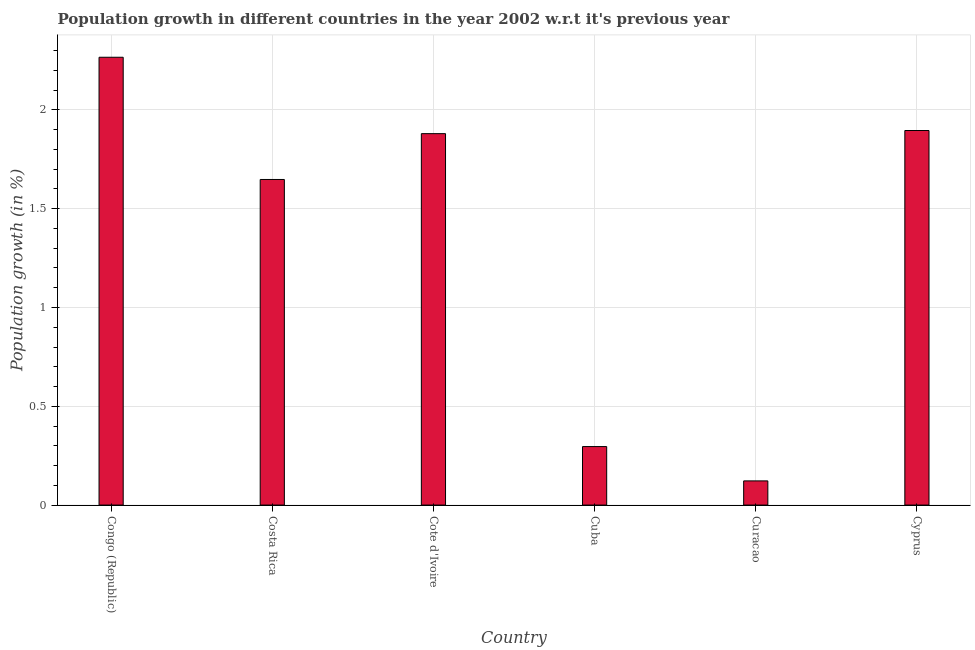What is the title of the graph?
Keep it short and to the point. Population growth in different countries in the year 2002 w.r.t it's previous year. What is the label or title of the X-axis?
Give a very brief answer. Country. What is the label or title of the Y-axis?
Your answer should be very brief. Population growth (in %). What is the population growth in Congo (Republic)?
Offer a terse response. 2.27. Across all countries, what is the maximum population growth?
Ensure brevity in your answer.  2.27. Across all countries, what is the minimum population growth?
Your answer should be very brief. 0.12. In which country was the population growth maximum?
Give a very brief answer. Congo (Republic). In which country was the population growth minimum?
Provide a succinct answer. Curacao. What is the sum of the population growth?
Provide a succinct answer. 8.11. What is the difference between the population growth in Cuba and Curacao?
Your answer should be very brief. 0.17. What is the average population growth per country?
Ensure brevity in your answer.  1.35. What is the median population growth?
Provide a short and direct response. 1.76. What is the ratio of the population growth in Congo (Republic) to that in Cyprus?
Your response must be concise. 1.2. Is the difference between the population growth in Costa Rica and Cyprus greater than the difference between any two countries?
Provide a succinct answer. No. What is the difference between the highest and the second highest population growth?
Keep it short and to the point. 0.37. Is the sum of the population growth in Costa Rica and Cote d'Ivoire greater than the maximum population growth across all countries?
Make the answer very short. Yes. What is the difference between the highest and the lowest population growth?
Offer a terse response. 2.14. In how many countries, is the population growth greater than the average population growth taken over all countries?
Give a very brief answer. 4. How many bars are there?
Your response must be concise. 6. How many countries are there in the graph?
Provide a short and direct response. 6. Are the values on the major ticks of Y-axis written in scientific E-notation?
Give a very brief answer. No. What is the Population growth (in %) in Congo (Republic)?
Your answer should be compact. 2.27. What is the Population growth (in %) of Costa Rica?
Offer a terse response. 1.65. What is the Population growth (in %) of Cote d'Ivoire?
Ensure brevity in your answer.  1.88. What is the Population growth (in %) in Cuba?
Keep it short and to the point. 0.3. What is the Population growth (in %) of Curacao?
Your answer should be very brief. 0.12. What is the Population growth (in %) of Cyprus?
Your response must be concise. 1.9. What is the difference between the Population growth (in %) in Congo (Republic) and Costa Rica?
Give a very brief answer. 0.62. What is the difference between the Population growth (in %) in Congo (Republic) and Cote d'Ivoire?
Provide a short and direct response. 0.39. What is the difference between the Population growth (in %) in Congo (Republic) and Cuba?
Your answer should be very brief. 1.97. What is the difference between the Population growth (in %) in Congo (Republic) and Curacao?
Keep it short and to the point. 2.14. What is the difference between the Population growth (in %) in Congo (Republic) and Cyprus?
Your answer should be compact. 0.37. What is the difference between the Population growth (in %) in Costa Rica and Cote d'Ivoire?
Offer a terse response. -0.23. What is the difference between the Population growth (in %) in Costa Rica and Cuba?
Give a very brief answer. 1.35. What is the difference between the Population growth (in %) in Costa Rica and Curacao?
Your answer should be compact. 1.53. What is the difference between the Population growth (in %) in Costa Rica and Cyprus?
Provide a succinct answer. -0.25. What is the difference between the Population growth (in %) in Cote d'Ivoire and Cuba?
Make the answer very short. 1.58. What is the difference between the Population growth (in %) in Cote d'Ivoire and Curacao?
Give a very brief answer. 1.76. What is the difference between the Population growth (in %) in Cote d'Ivoire and Cyprus?
Make the answer very short. -0.02. What is the difference between the Population growth (in %) in Cuba and Curacao?
Provide a short and direct response. 0.17. What is the difference between the Population growth (in %) in Cuba and Cyprus?
Offer a very short reply. -1.6. What is the difference between the Population growth (in %) in Curacao and Cyprus?
Your answer should be compact. -1.77. What is the ratio of the Population growth (in %) in Congo (Republic) to that in Costa Rica?
Offer a very short reply. 1.38. What is the ratio of the Population growth (in %) in Congo (Republic) to that in Cote d'Ivoire?
Offer a very short reply. 1.21. What is the ratio of the Population growth (in %) in Congo (Republic) to that in Cuba?
Keep it short and to the point. 7.65. What is the ratio of the Population growth (in %) in Congo (Republic) to that in Curacao?
Offer a very short reply. 18.52. What is the ratio of the Population growth (in %) in Congo (Republic) to that in Cyprus?
Give a very brief answer. 1.2. What is the ratio of the Population growth (in %) in Costa Rica to that in Cote d'Ivoire?
Give a very brief answer. 0.88. What is the ratio of the Population growth (in %) in Costa Rica to that in Cuba?
Make the answer very short. 5.57. What is the ratio of the Population growth (in %) in Costa Rica to that in Curacao?
Ensure brevity in your answer.  13.47. What is the ratio of the Population growth (in %) in Costa Rica to that in Cyprus?
Provide a short and direct response. 0.87. What is the ratio of the Population growth (in %) in Cote d'Ivoire to that in Cuba?
Your answer should be compact. 6.35. What is the ratio of the Population growth (in %) in Cote d'Ivoire to that in Curacao?
Ensure brevity in your answer.  15.36. What is the ratio of the Population growth (in %) in Cuba to that in Curacao?
Make the answer very short. 2.42. What is the ratio of the Population growth (in %) in Cuba to that in Cyprus?
Offer a very short reply. 0.16. What is the ratio of the Population growth (in %) in Curacao to that in Cyprus?
Ensure brevity in your answer.  0.07. 